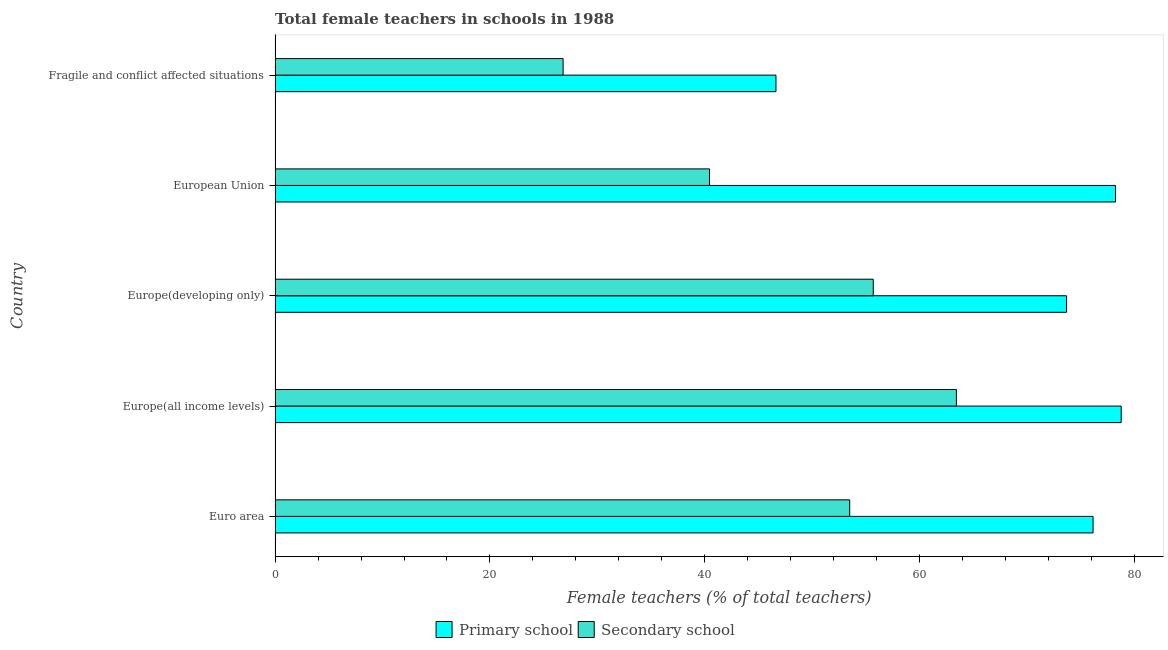How many groups of bars are there?
Provide a short and direct response. 5. Are the number of bars on each tick of the Y-axis equal?
Provide a short and direct response. Yes. What is the label of the 3rd group of bars from the top?
Make the answer very short. Europe(developing only). What is the percentage of female teachers in primary schools in European Union?
Your response must be concise. 78.22. Across all countries, what is the maximum percentage of female teachers in primary schools?
Make the answer very short. 78.75. Across all countries, what is the minimum percentage of female teachers in primary schools?
Your response must be concise. 46.62. In which country was the percentage of female teachers in secondary schools maximum?
Provide a short and direct response. Europe(all income levels). In which country was the percentage of female teachers in secondary schools minimum?
Your answer should be very brief. Fragile and conflict affected situations. What is the total percentage of female teachers in primary schools in the graph?
Provide a short and direct response. 353.39. What is the difference between the percentage of female teachers in primary schools in Europe(developing only) and that in European Union?
Make the answer very short. -4.55. What is the difference between the percentage of female teachers in primary schools in Euro area and the percentage of female teachers in secondary schools in European Union?
Ensure brevity in your answer.  35.7. What is the average percentage of female teachers in secondary schools per country?
Provide a short and direct response. 47.96. What is the difference between the percentage of female teachers in primary schools and percentage of female teachers in secondary schools in European Union?
Give a very brief answer. 37.78. What is the ratio of the percentage of female teachers in secondary schools in Europe(developing only) to that in European Union?
Keep it short and to the point. 1.38. Is the percentage of female teachers in primary schools in Europe(all income levels) less than that in European Union?
Your response must be concise. No. Is the difference between the percentage of female teachers in secondary schools in Europe(all income levels) and European Union greater than the difference between the percentage of female teachers in primary schools in Europe(all income levels) and European Union?
Ensure brevity in your answer.  Yes. What is the difference between the highest and the second highest percentage of female teachers in secondary schools?
Keep it short and to the point. 7.74. What is the difference between the highest and the lowest percentage of female teachers in primary schools?
Your response must be concise. 32.13. In how many countries, is the percentage of female teachers in primary schools greater than the average percentage of female teachers in primary schools taken over all countries?
Offer a terse response. 4. What does the 1st bar from the top in Euro area represents?
Give a very brief answer. Secondary school. What does the 2nd bar from the bottom in Euro area represents?
Your response must be concise. Secondary school. Are all the bars in the graph horizontal?
Offer a terse response. Yes. How many countries are there in the graph?
Your response must be concise. 5. What is the difference between two consecutive major ticks on the X-axis?
Give a very brief answer. 20. Does the graph contain grids?
Make the answer very short. No. How are the legend labels stacked?
Your response must be concise. Horizontal. What is the title of the graph?
Give a very brief answer. Total female teachers in schools in 1988. Does "Passenger Transport Items" appear as one of the legend labels in the graph?
Ensure brevity in your answer.  No. What is the label or title of the X-axis?
Your response must be concise. Female teachers (% of total teachers). What is the Female teachers (% of total teachers) of Primary school in Euro area?
Your response must be concise. 76.13. What is the Female teachers (% of total teachers) of Secondary school in Euro area?
Offer a terse response. 53.48. What is the Female teachers (% of total teachers) of Primary school in Europe(all income levels)?
Make the answer very short. 78.75. What is the Female teachers (% of total teachers) in Secondary school in Europe(all income levels)?
Give a very brief answer. 63.41. What is the Female teachers (% of total teachers) in Primary school in Europe(developing only)?
Make the answer very short. 73.67. What is the Female teachers (% of total teachers) in Secondary school in Europe(developing only)?
Make the answer very short. 55.67. What is the Female teachers (% of total teachers) in Primary school in European Union?
Give a very brief answer. 78.22. What is the Female teachers (% of total teachers) of Secondary school in European Union?
Offer a very short reply. 40.43. What is the Female teachers (% of total teachers) of Primary school in Fragile and conflict affected situations?
Offer a very short reply. 46.62. What is the Female teachers (% of total teachers) in Secondary school in Fragile and conflict affected situations?
Your answer should be very brief. 26.81. Across all countries, what is the maximum Female teachers (% of total teachers) of Primary school?
Give a very brief answer. 78.75. Across all countries, what is the maximum Female teachers (% of total teachers) in Secondary school?
Provide a short and direct response. 63.41. Across all countries, what is the minimum Female teachers (% of total teachers) of Primary school?
Give a very brief answer. 46.62. Across all countries, what is the minimum Female teachers (% of total teachers) of Secondary school?
Offer a very short reply. 26.81. What is the total Female teachers (% of total teachers) in Primary school in the graph?
Provide a short and direct response. 353.39. What is the total Female teachers (% of total teachers) of Secondary school in the graph?
Ensure brevity in your answer.  239.81. What is the difference between the Female teachers (% of total teachers) in Primary school in Euro area and that in Europe(all income levels)?
Your answer should be very brief. -2.62. What is the difference between the Female teachers (% of total teachers) in Secondary school in Euro area and that in Europe(all income levels)?
Provide a short and direct response. -9.93. What is the difference between the Female teachers (% of total teachers) of Primary school in Euro area and that in Europe(developing only)?
Give a very brief answer. 2.47. What is the difference between the Female teachers (% of total teachers) in Secondary school in Euro area and that in Europe(developing only)?
Give a very brief answer. -2.19. What is the difference between the Female teachers (% of total teachers) in Primary school in Euro area and that in European Union?
Keep it short and to the point. -2.09. What is the difference between the Female teachers (% of total teachers) of Secondary school in Euro area and that in European Union?
Make the answer very short. 13.05. What is the difference between the Female teachers (% of total teachers) in Primary school in Euro area and that in Fragile and conflict affected situations?
Offer a terse response. 29.52. What is the difference between the Female teachers (% of total teachers) in Secondary school in Euro area and that in Fragile and conflict affected situations?
Offer a terse response. 26.67. What is the difference between the Female teachers (% of total teachers) in Primary school in Europe(all income levels) and that in Europe(developing only)?
Provide a short and direct response. 5.08. What is the difference between the Female teachers (% of total teachers) of Secondary school in Europe(all income levels) and that in Europe(developing only)?
Keep it short and to the point. 7.74. What is the difference between the Female teachers (% of total teachers) in Primary school in Europe(all income levels) and that in European Union?
Your response must be concise. 0.53. What is the difference between the Female teachers (% of total teachers) in Secondary school in Europe(all income levels) and that in European Union?
Your answer should be very brief. 22.98. What is the difference between the Female teachers (% of total teachers) of Primary school in Europe(all income levels) and that in Fragile and conflict affected situations?
Make the answer very short. 32.13. What is the difference between the Female teachers (% of total teachers) in Secondary school in Europe(all income levels) and that in Fragile and conflict affected situations?
Offer a very short reply. 36.61. What is the difference between the Female teachers (% of total teachers) of Primary school in Europe(developing only) and that in European Union?
Your answer should be compact. -4.55. What is the difference between the Female teachers (% of total teachers) of Secondary school in Europe(developing only) and that in European Union?
Offer a very short reply. 15.24. What is the difference between the Female teachers (% of total teachers) in Primary school in Europe(developing only) and that in Fragile and conflict affected situations?
Your response must be concise. 27.05. What is the difference between the Female teachers (% of total teachers) of Secondary school in Europe(developing only) and that in Fragile and conflict affected situations?
Your answer should be compact. 28.87. What is the difference between the Female teachers (% of total teachers) in Primary school in European Union and that in Fragile and conflict affected situations?
Your response must be concise. 31.6. What is the difference between the Female teachers (% of total teachers) of Secondary school in European Union and that in Fragile and conflict affected situations?
Offer a terse response. 13.63. What is the difference between the Female teachers (% of total teachers) in Primary school in Euro area and the Female teachers (% of total teachers) in Secondary school in Europe(all income levels)?
Offer a terse response. 12.72. What is the difference between the Female teachers (% of total teachers) in Primary school in Euro area and the Female teachers (% of total teachers) in Secondary school in Europe(developing only)?
Offer a terse response. 20.46. What is the difference between the Female teachers (% of total teachers) in Primary school in Euro area and the Female teachers (% of total teachers) in Secondary school in European Union?
Offer a very short reply. 35.7. What is the difference between the Female teachers (% of total teachers) in Primary school in Euro area and the Female teachers (% of total teachers) in Secondary school in Fragile and conflict affected situations?
Provide a short and direct response. 49.33. What is the difference between the Female teachers (% of total teachers) in Primary school in Europe(all income levels) and the Female teachers (% of total teachers) in Secondary school in Europe(developing only)?
Your answer should be very brief. 23.07. What is the difference between the Female teachers (% of total teachers) of Primary school in Europe(all income levels) and the Female teachers (% of total teachers) of Secondary school in European Union?
Give a very brief answer. 38.31. What is the difference between the Female teachers (% of total teachers) of Primary school in Europe(all income levels) and the Female teachers (% of total teachers) of Secondary school in Fragile and conflict affected situations?
Provide a succinct answer. 51.94. What is the difference between the Female teachers (% of total teachers) of Primary school in Europe(developing only) and the Female teachers (% of total teachers) of Secondary school in European Union?
Provide a short and direct response. 33.23. What is the difference between the Female teachers (% of total teachers) in Primary school in Europe(developing only) and the Female teachers (% of total teachers) in Secondary school in Fragile and conflict affected situations?
Offer a terse response. 46.86. What is the difference between the Female teachers (% of total teachers) in Primary school in European Union and the Female teachers (% of total teachers) in Secondary school in Fragile and conflict affected situations?
Keep it short and to the point. 51.41. What is the average Female teachers (% of total teachers) in Primary school per country?
Provide a short and direct response. 70.68. What is the average Female teachers (% of total teachers) of Secondary school per country?
Keep it short and to the point. 47.96. What is the difference between the Female teachers (% of total teachers) of Primary school and Female teachers (% of total teachers) of Secondary school in Euro area?
Give a very brief answer. 22.65. What is the difference between the Female teachers (% of total teachers) of Primary school and Female teachers (% of total teachers) of Secondary school in Europe(all income levels)?
Keep it short and to the point. 15.34. What is the difference between the Female teachers (% of total teachers) of Primary school and Female teachers (% of total teachers) of Secondary school in Europe(developing only)?
Your response must be concise. 17.99. What is the difference between the Female teachers (% of total teachers) in Primary school and Female teachers (% of total teachers) in Secondary school in European Union?
Provide a succinct answer. 37.79. What is the difference between the Female teachers (% of total teachers) of Primary school and Female teachers (% of total teachers) of Secondary school in Fragile and conflict affected situations?
Your answer should be compact. 19.81. What is the ratio of the Female teachers (% of total teachers) of Primary school in Euro area to that in Europe(all income levels)?
Offer a very short reply. 0.97. What is the ratio of the Female teachers (% of total teachers) of Secondary school in Euro area to that in Europe(all income levels)?
Give a very brief answer. 0.84. What is the ratio of the Female teachers (% of total teachers) in Primary school in Euro area to that in Europe(developing only)?
Provide a short and direct response. 1.03. What is the ratio of the Female teachers (% of total teachers) in Secondary school in Euro area to that in Europe(developing only)?
Provide a succinct answer. 0.96. What is the ratio of the Female teachers (% of total teachers) of Primary school in Euro area to that in European Union?
Your answer should be compact. 0.97. What is the ratio of the Female teachers (% of total teachers) of Secondary school in Euro area to that in European Union?
Ensure brevity in your answer.  1.32. What is the ratio of the Female teachers (% of total teachers) in Primary school in Euro area to that in Fragile and conflict affected situations?
Offer a terse response. 1.63. What is the ratio of the Female teachers (% of total teachers) of Secondary school in Euro area to that in Fragile and conflict affected situations?
Your response must be concise. 2. What is the ratio of the Female teachers (% of total teachers) of Primary school in Europe(all income levels) to that in Europe(developing only)?
Make the answer very short. 1.07. What is the ratio of the Female teachers (% of total teachers) in Secondary school in Europe(all income levels) to that in Europe(developing only)?
Offer a very short reply. 1.14. What is the ratio of the Female teachers (% of total teachers) of Primary school in Europe(all income levels) to that in European Union?
Ensure brevity in your answer.  1.01. What is the ratio of the Female teachers (% of total teachers) of Secondary school in Europe(all income levels) to that in European Union?
Offer a terse response. 1.57. What is the ratio of the Female teachers (% of total teachers) in Primary school in Europe(all income levels) to that in Fragile and conflict affected situations?
Make the answer very short. 1.69. What is the ratio of the Female teachers (% of total teachers) of Secondary school in Europe(all income levels) to that in Fragile and conflict affected situations?
Keep it short and to the point. 2.37. What is the ratio of the Female teachers (% of total teachers) of Primary school in Europe(developing only) to that in European Union?
Make the answer very short. 0.94. What is the ratio of the Female teachers (% of total teachers) in Secondary school in Europe(developing only) to that in European Union?
Offer a terse response. 1.38. What is the ratio of the Female teachers (% of total teachers) in Primary school in Europe(developing only) to that in Fragile and conflict affected situations?
Ensure brevity in your answer.  1.58. What is the ratio of the Female teachers (% of total teachers) of Secondary school in Europe(developing only) to that in Fragile and conflict affected situations?
Provide a succinct answer. 2.08. What is the ratio of the Female teachers (% of total teachers) of Primary school in European Union to that in Fragile and conflict affected situations?
Your response must be concise. 1.68. What is the ratio of the Female teachers (% of total teachers) of Secondary school in European Union to that in Fragile and conflict affected situations?
Your answer should be compact. 1.51. What is the difference between the highest and the second highest Female teachers (% of total teachers) in Primary school?
Your answer should be very brief. 0.53. What is the difference between the highest and the second highest Female teachers (% of total teachers) in Secondary school?
Give a very brief answer. 7.74. What is the difference between the highest and the lowest Female teachers (% of total teachers) of Primary school?
Keep it short and to the point. 32.13. What is the difference between the highest and the lowest Female teachers (% of total teachers) in Secondary school?
Keep it short and to the point. 36.61. 